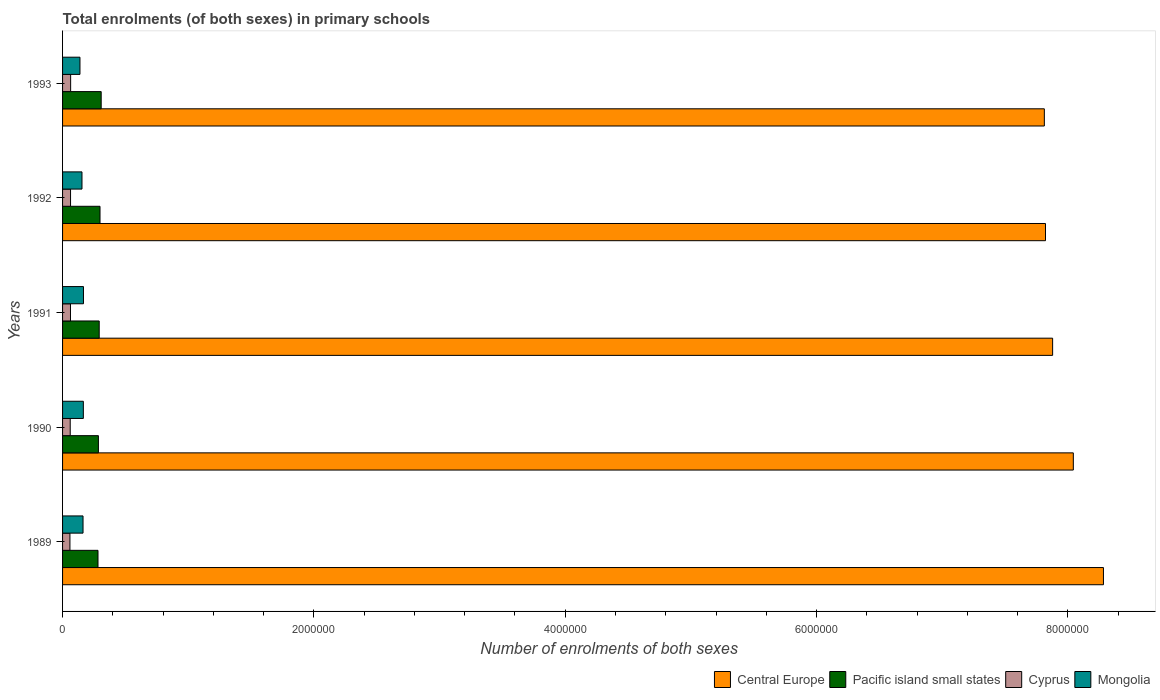Are the number of bars on each tick of the Y-axis equal?
Provide a succinct answer. Yes. What is the label of the 3rd group of bars from the top?
Offer a terse response. 1991. In how many cases, is the number of bars for a given year not equal to the number of legend labels?
Keep it short and to the point. 0. What is the number of enrolments in primary schools in Mongolia in 1993?
Your answer should be very brief. 1.38e+05. Across all years, what is the maximum number of enrolments in primary schools in Central Europe?
Keep it short and to the point. 8.28e+06. Across all years, what is the minimum number of enrolments in primary schools in Central Europe?
Offer a very short reply. 7.81e+06. What is the total number of enrolments in primary schools in Cyprus in the graph?
Your answer should be very brief. 3.10e+05. What is the difference between the number of enrolments in primary schools in Cyprus in 1989 and that in 1990?
Offer a very short reply. -2121. What is the difference between the number of enrolments in primary schools in Pacific island small states in 1991 and the number of enrolments in primary schools in Mongolia in 1989?
Keep it short and to the point. 1.29e+05. What is the average number of enrolments in primary schools in Central Europe per year?
Provide a short and direct response. 7.97e+06. In the year 1992, what is the difference between the number of enrolments in primary schools in Central Europe and number of enrolments in primary schools in Pacific island small states?
Make the answer very short. 7.52e+06. What is the ratio of the number of enrolments in primary schools in Pacific island small states in 1990 to that in 1991?
Provide a succinct answer. 0.98. Is the difference between the number of enrolments in primary schools in Central Europe in 1991 and 1992 greater than the difference between the number of enrolments in primary schools in Pacific island small states in 1991 and 1992?
Your response must be concise. Yes. What is the difference between the highest and the second highest number of enrolments in primary schools in Pacific island small states?
Offer a very short reply. 9341.28. What is the difference between the highest and the lowest number of enrolments in primary schools in Mongolia?
Offer a very short reply. 2.79e+04. In how many years, is the number of enrolments in primary schools in Central Europe greater than the average number of enrolments in primary schools in Central Europe taken over all years?
Your response must be concise. 2. Is the sum of the number of enrolments in primary schools in Central Europe in 1989 and 1990 greater than the maximum number of enrolments in primary schools in Mongolia across all years?
Give a very brief answer. Yes. Is it the case that in every year, the sum of the number of enrolments in primary schools in Mongolia and number of enrolments in primary schools in Cyprus is greater than the sum of number of enrolments in primary schools in Central Europe and number of enrolments in primary schools in Pacific island small states?
Keep it short and to the point. No. What does the 2nd bar from the top in 1991 represents?
Your response must be concise. Cyprus. What does the 1st bar from the bottom in 1989 represents?
Your answer should be very brief. Central Europe. Does the graph contain any zero values?
Offer a very short reply. No. Does the graph contain grids?
Offer a very short reply. No. Where does the legend appear in the graph?
Provide a short and direct response. Bottom right. How many legend labels are there?
Your response must be concise. 4. What is the title of the graph?
Give a very brief answer. Total enrolments (of both sexes) in primary schools. Does "Oman" appear as one of the legend labels in the graph?
Offer a terse response. No. What is the label or title of the X-axis?
Provide a short and direct response. Number of enrolments of both sexes. What is the label or title of the Y-axis?
Provide a short and direct response. Years. What is the Number of enrolments of both sexes in Central Europe in 1989?
Keep it short and to the point. 8.28e+06. What is the Number of enrolments of both sexes in Pacific island small states in 1989?
Provide a succinct answer. 2.82e+05. What is the Number of enrolments of both sexes of Cyprus in 1989?
Give a very brief answer. 5.87e+04. What is the Number of enrolments of both sexes in Mongolia in 1989?
Keep it short and to the point. 1.63e+05. What is the Number of enrolments of both sexes in Central Europe in 1990?
Provide a short and direct response. 8.04e+06. What is the Number of enrolments of both sexes of Pacific island small states in 1990?
Offer a very short reply. 2.85e+05. What is the Number of enrolments of both sexes in Cyprus in 1990?
Make the answer very short. 6.08e+04. What is the Number of enrolments of both sexes in Mongolia in 1990?
Make the answer very short. 1.65e+05. What is the Number of enrolments of both sexes in Central Europe in 1991?
Provide a succinct answer. 7.88e+06. What is the Number of enrolments of both sexes of Pacific island small states in 1991?
Offer a terse response. 2.92e+05. What is the Number of enrolments of both sexes in Cyprus in 1991?
Provide a succinct answer. 6.30e+04. What is the Number of enrolments of both sexes of Mongolia in 1991?
Offer a terse response. 1.66e+05. What is the Number of enrolments of both sexes in Central Europe in 1992?
Provide a short and direct response. 7.82e+06. What is the Number of enrolments of both sexes of Pacific island small states in 1992?
Provide a succinct answer. 2.98e+05. What is the Number of enrolments of both sexes of Cyprus in 1992?
Provide a short and direct response. 6.35e+04. What is the Number of enrolments of both sexes in Mongolia in 1992?
Keep it short and to the point. 1.55e+05. What is the Number of enrolments of both sexes of Central Europe in 1993?
Your response must be concise. 7.81e+06. What is the Number of enrolments of both sexes in Pacific island small states in 1993?
Your response must be concise. 3.07e+05. What is the Number of enrolments of both sexes in Cyprus in 1993?
Offer a terse response. 6.43e+04. What is the Number of enrolments of both sexes of Mongolia in 1993?
Offer a very short reply. 1.38e+05. Across all years, what is the maximum Number of enrolments of both sexes of Central Europe?
Keep it short and to the point. 8.28e+06. Across all years, what is the maximum Number of enrolments of both sexes in Pacific island small states?
Your answer should be compact. 3.07e+05. Across all years, what is the maximum Number of enrolments of both sexes in Cyprus?
Make the answer very short. 6.43e+04. Across all years, what is the maximum Number of enrolments of both sexes in Mongolia?
Ensure brevity in your answer.  1.66e+05. Across all years, what is the minimum Number of enrolments of both sexes of Central Europe?
Keep it short and to the point. 7.81e+06. Across all years, what is the minimum Number of enrolments of both sexes in Pacific island small states?
Offer a terse response. 2.82e+05. Across all years, what is the minimum Number of enrolments of both sexes in Cyprus?
Provide a short and direct response. 5.87e+04. Across all years, what is the minimum Number of enrolments of both sexes in Mongolia?
Your answer should be very brief. 1.38e+05. What is the total Number of enrolments of both sexes in Central Europe in the graph?
Offer a very short reply. 3.98e+07. What is the total Number of enrolments of both sexes in Pacific island small states in the graph?
Provide a succinct answer. 1.46e+06. What is the total Number of enrolments of both sexes in Cyprus in the graph?
Provide a short and direct response. 3.10e+05. What is the total Number of enrolments of both sexes of Mongolia in the graph?
Make the answer very short. 7.88e+05. What is the difference between the Number of enrolments of both sexes of Central Europe in 1989 and that in 1990?
Offer a very short reply. 2.40e+05. What is the difference between the Number of enrolments of both sexes of Pacific island small states in 1989 and that in 1990?
Offer a terse response. -3343.72. What is the difference between the Number of enrolments of both sexes of Cyprus in 1989 and that in 1990?
Your answer should be very brief. -2121. What is the difference between the Number of enrolments of both sexes of Mongolia in 1989 and that in 1990?
Ensure brevity in your answer.  -2500. What is the difference between the Number of enrolments of both sexes of Central Europe in 1989 and that in 1991?
Your answer should be compact. 4.04e+05. What is the difference between the Number of enrolments of both sexes of Pacific island small states in 1989 and that in 1991?
Offer a very short reply. -9645.75. What is the difference between the Number of enrolments of both sexes in Cyprus in 1989 and that in 1991?
Offer a very short reply. -4242. What is the difference between the Number of enrolments of both sexes of Mongolia in 1989 and that in 1991?
Your response must be concise. -3449. What is the difference between the Number of enrolments of both sexes of Central Europe in 1989 and that in 1992?
Keep it short and to the point. 4.61e+05. What is the difference between the Number of enrolments of both sexes in Pacific island small states in 1989 and that in 1992?
Offer a very short reply. -1.61e+04. What is the difference between the Number of enrolments of both sexes of Cyprus in 1989 and that in 1992?
Give a very brief answer. -4734. What is the difference between the Number of enrolments of both sexes of Mongolia in 1989 and that in 1992?
Provide a short and direct response. 8312. What is the difference between the Number of enrolments of both sexes in Central Europe in 1989 and that in 1993?
Offer a very short reply. 4.70e+05. What is the difference between the Number of enrolments of both sexes of Pacific island small states in 1989 and that in 1993?
Your answer should be very brief. -2.54e+04. What is the difference between the Number of enrolments of both sexes in Cyprus in 1989 and that in 1993?
Your response must be concise. -5593. What is the difference between the Number of enrolments of both sexes of Mongolia in 1989 and that in 1993?
Offer a terse response. 2.45e+04. What is the difference between the Number of enrolments of both sexes of Central Europe in 1990 and that in 1991?
Offer a very short reply. 1.65e+05. What is the difference between the Number of enrolments of both sexes of Pacific island small states in 1990 and that in 1991?
Provide a short and direct response. -6302.03. What is the difference between the Number of enrolments of both sexes in Cyprus in 1990 and that in 1991?
Provide a short and direct response. -2121. What is the difference between the Number of enrolments of both sexes of Mongolia in 1990 and that in 1991?
Offer a very short reply. -949. What is the difference between the Number of enrolments of both sexes of Central Europe in 1990 and that in 1992?
Keep it short and to the point. 2.22e+05. What is the difference between the Number of enrolments of both sexes in Pacific island small states in 1990 and that in 1992?
Offer a terse response. -1.27e+04. What is the difference between the Number of enrolments of both sexes of Cyprus in 1990 and that in 1992?
Provide a short and direct response. -2613. What is the difference between the Number of enrolments of both sexes of Mongolia in 1990 and that in 1992?
Your answer should be very brief. 1.08e+04. What is the difference between the Number of enrolments of both sexes of Central Europe in 1990 and that in 1993?
Provide a succinct answer. 2.31e+05. What is the difference between the Number of enrolments of both sexes of Pacific island small states in 1990 and that in 1993?
Your answer should be compact. -2.21e+04. What is the difference between the Number of enrolments of both sexes in Cyprus in 1990 and that in 1993?
Give a very brief answer. -3472. What is the difference between the Number of enrolments of both sexes of Mongolia in 1990 and that in 1993?
Make the answer very short. 2.70e+04. What is the difference between the Number of enrolments of both sexes of Central Europe in 1991 and that in 1992?
Offer a terse response. 5.67e+04. What is the difference between the Number of enrolments of both sexes in Pacific island small states in 1991 and that in 1992?
Make the answer very short. -6427.69. What is the difference between the Number of enrolments of both sexes of Cyprus in 1991 and that in 1992?
Offer a very short reply. -492. What is the difference between the Number of enrolments of both sexes in Mongolia in 1991 and that in 1992?
Provide a succinct answer. 1.18e+04. What is the difference between the Number of enrolments of both sexes in Central Europe in 1991 and that in 1993?
Your answer should be very brief. 6.59e+04. What is the difference between the Number of enrolments of both sexes in Pacific island small states in 1991 and that in 1993?
Offer a very short reply. -1.58e+04. What is the difference between the Number of enrolments of both sexes in Cyprus in 1991 and that in 1993?
Make the answer very short. -1351. What is the difference between the Number of enrolments of both sexes in Mongolia in 1991 and that in 1993?
Make the answer very short. 2.79e+04. What is the difference between the Number of enrolments of both sexes of Central Europe in 1992 and that in 1993?
Your response must be concise. 9198. What is the difference between the Number of enrolments of both sexes in Pacific island small states in 1992 and that in 1993?
Your answer should be compact. -9341.28. What is the difference between the Number of enrolments of both sexes of Cyprus in 1992 and that in 1993?
Keep it short and to the point. -859. What is the difference between the Number of enrolments of both sexes of Mongolia in 1992 and that in 1993?
Keep it short and to the point. 1.62e+04. What is the difference between the Number of enrolments of both sexes of Central Europe in 1989 and the Number of enrolments of both sexes of Pacific island small states in 1990?
Give a very brief answer. 8.00e+06. What is the difference between the Number of enrolments of both sexes in Central Europe in 1989 and the Number of enrolments of both sexes in Cyprus in 1990?
Keep it short and to the point. 8.22e+06. What is the difference between the Number of enrolments of both sexes of Central Europe in 1989 and the Number of enrolments of both sexes of Mongolia in 1990?
Provide a succinct answer. 8.12e+06. What is the difference between the Number of enrolments of both sexes of Pacific island small states in 1989 and the Number of enrolments of both sexes of Cyprus in 1990?
Your answer should be compact. 2.21e+05. What is the difference between the Number of enrolments of both sexes of Pacific island small states in 1989 and the Number of enrolments of both sexes of Mongolia in 1990?
Provide a short and direct response. 1.17e+05. What is the difference between the Number of enrolments of both sexes in Cyprus in 1989 and the Number of enrolments of both sexes in Mongolia in 1990?
Ensure brevity in your answer.  -1.07e+05. What is the difference between the Number of enrolments of both sexes of Central Europe in 1989 and the Number of enrolments of both sexes of Pacific island small states in 1991?
Provide a succinct answer. 7.99e+06. What is the difference between the Number of enrolments of both sexes in Central Europe in 1989 and the Number of enrolments of both sexes in Cyprus in 1991?
Provide a short and direct response. 8.22e+06. What is the difference between the Number of enrolments of both sexes in Central Europe in 1989 and the Number of enrolments of both sexes in Mongolia in 1991?
Offer a terse response. 8.12e+06. What is the difference between the Number of enrolments of both sexes of Pacific island small states in 1989 and the Number of enrolments of both sexes of Cyprus in 1991?
Your answer should be compact. 2.19e+05. What is the difference between the Number of enrolments of both sexes of Pacific island small states in 1989 and the Number of enrolments of both sexes of Mongolia in 1991?
Give a very brief answer. 1.16e+05. What is the difference between the Number of enrolments of both sexes in Cyprus in 1989 and the Number of enrolments of both sexes in Mongolia in 1991?
Give a very brief answer. -1.08e+05. What is the difference between the Number of enrolments of both sexes of Central Europe in 1989 and the Number of enrolments of both sexes of Pacific island small states in 1992?
Your response must be concise. 7.99e+06. What is the difference between the Number of enrolments of both sexes of Central Europe in 1989 and the Number of enrolments of both sexes of Cyprus in 1992?
Offer a terse response. 8.22e+06. What is the difference between the Number of enrolments of both sexes in Central Europe in 1989 and the Number of enrolments of both sexes in Mongolia in 1992?
Your answer should be very brief. 8.13e+06. What is the difference between the Number of enrolments of both sexes in Pacific island small states in 1989 and the Number of enrolments of both sexes in Cyprus in 1992?
Offer a terse response. 2.18e+05. What is the difference between the Number of enrolments of both sexes of Pacific island small states in 1989 and the Number of enrolments of both sexes of Mongolia in 1992?
Your response must be concise. 1.27e+05. What is the difference between the Number of enrolments of both sexes of Cyprus in 1989 and the Number of enrolments of both sexes of Mongolia in 1992?
Keep it short and to the point. -9.59e+04. What is the difference between the Number of enrolments of both sexes in Central Europe in 1989 and the Number of enrolments of both sexes in Pacific island small states in 1993?
Provide a succinct answer. 7.98e+06. What is the difference between the Number of enrolments of both sexes of Central Europe in 1989 and the Number of enrolments of both sexes of Cyprus in 1993?
Ensure brevity in your answer.  8.22e+06. What is the difference between the Number of enrolments of both sexes of Central Europe in 1989 and the Number of enrolments of both sexes of Mongolia in 1993?
Provide a succinct answer. 8.14e+06. What is the difference between the Number of enrolments of both sexes in Pacific island small states in 1989 and the Number of enrolments of both sexes in Cyprus in 1993?
Keep it short and to the point. 2.18e+05. What is the difference between the Number of enrolments of both sexes of Pacific island small states in 1989 and the Number of enrolments of both sexes of Mongolia in 1993?
Make the answer very short. 1.43e+05. What is the difference between the Number of enrolments of both sexes of Cyprus in 1989 and the Number of enrolments of both sexes of Mongolia in 1993?
Provide a short and direct response. -7.97e+04. What is the difference between the Number of enrolments of both sexes of Central Europe in 1990 and the Number of enrolments of both sexes of Pacific island small states in 1991?
Provide a succinct answer. 7.75e+06. What is the difference between the Number of enrolments of both sexes of Central Europe in 1990 and the Number of enrolments of both sexes of Cyprus in 1991?
Your answer should be very brief. 7.98e+06. What is the difference between the Number of enrolments of both sexes of Central Europe in 1990 and the Number of enrolments of both sexes of Mongolia in 1991?
Your answer should be compact. 7.88e+06. What is the difference between the Number of enrolments of both sexes of Pacific island small states in 1990 and the Number of enrolments of both sexes of Cyprus in 1991?
Offer a terse response. 2.22e+05. What is the difference between the Number of enrolments of both sexes of Pacific island small states in 1990 and the Number of enrolments of both sexes of Mongolia in 1991?
Offer a very short reply. 1.19e+05. What is the difference between the Number of enrolments of both sexes of Cyprus in 1990 and the Number of enrolments of both sexes of Mongolia in 1991?
Offer a very short reply. -1.06e+05. What is the difference between the Number of enrolments of both sexes in Central Europe in 1990 and the Number of enrolments of both sexes in Pacific island small states in 1992?
Keep it short and to the point. 7.75e+06. What is the difference between the Number of enrolments of both sexes of Central Europe in 1990 and the Number of enrolments of both sexes of Cyprus in 1992?
Offer a terse response. 7.98e+06. What is the difference between the Number of enrolments of both sexes of Central Europe in 1990 and the Number of enrolments of both sexes of Mongolia in 1992?
Offer a very short reply. 7.89e+06. What is the difference between the Number of enrolments of both sexes of Pacific island small states in 1990 and the Number of enrolments of both sexes of Cyprus in 1992?
Your answer should be compact. 2.22e+05. What is the difference between the Number of enrolments of both sexes of Pacific island small states in 1990 and the Number of enrolments of both sexes of Mongolia in 1992?
Make the answer very short. 1.31e+05. What is the difference between the Number of enrolments of both sexes in Cyprus in 1990 and the Number of enrolments of both sexes in Mongolia in 1992?
Offer a very short reply. -9.37e+04. What is the difference between the Number of enrolments of both sexes in Central Europe in 1990 and the Number of enrolments of both sexes in Pacific island small states in 1993?
Keep it short and to the point. 7.74e+06. What is the difference between the Number of enrolments of both sexes in Central Europe in 1990 and the Number of enrolments of both sexes in Cyprus in 1993?
Offer a terse response. 7.98e+06. What is the difference between the Number of enrolments of both sexes in Central Europe in 1990 and the Number of enrolments of both sexes in Mongolia in 1993?
Make the answer very short. 7.90e+06. What is the difference between the Number of enrolments of both sexes in Pacific island small states in 1990 and the Number of enrolments of both sexes in Cyprus in 1993?
Provide a succinct answer. 2.21e+05. What is the difference between the Number of enrolments of both sexes of Pacific island small states in 1990 and the Number of enrolments of both sexes of Mongolia in 1993?
Your answer should be very brief. 1.47e+05. What is the difference between the Number of enrolments of both sexes in Cyprus in 1990 and the Number of enrolments of both sexes in Mongolia in 1993?
Ensure brevity in your answer.  -7.76e+04. What is the difference between the Number of enrolments of both sexes in Central Europe in 1991 and the Number of enrolments of both sexes in Pacific island small states in 1992?
Your response must be concise. 7.58e+06. What is the difference between the Number of enrolments of both sexes of Central Europe in 1991 and the Number of enrolments of both sexes of Cyprus in 1992?
Provide a succinct answer. 7.82e+06. What is the difference between the Number of enrolments of both sexes in Central Europe in 1991 and the Number of enrolments of both sexes in Mongolia in 1992?
Your answer should be very brief. 7.72e+06. What is the difference between the Number of enrolments of both sexes of Pacific island small states in 1991 and the Number of enrolments of both sexes of Cyprus in 1992?
Provide a succinct answer. 2.28e+05. What is the difference between the Number of enrolments of both sexes of Pacific island small states in 1991 and the Number of enrolments of both sexes of Mongolia in 1992?
Offer a very short reply. 1.37e+05. What is the difference between the Number of enrolments of both sexes in Cyprus in 1991 and the Number of enrolments of both sexes in Mongolia in 1992?
Provide a short and direct response. -9.16e+04. What is the difference between the Number of enrolments of both sexes of Central Europe in 1991 and the Number of enrolments of both sexes of Pacific island small states in 1993?
Keep it short and to the point. 7.57e+06. What is the difference between the Number of enrolments of both sexes of Central Europe in 1991 and the Number of enrolments of both sexes of Cyprus in 1993?
Ensure brevity in your answer.  7.81e+06. What is the difference between the Number of enrolments of both sexes of Central Europe in 1991 and the Number of enrolments of both sexes of Mongolia in 1993?
Your answer should be very brief. 7.74e+06. What is the difference between the Number of enrolments of both sexes in Pacific island small states in 1991 and the Number of enrolments of both sexes in Cyprus in 1993?
Offer a very short reply. 2.27e+05. What is the difference between the Number of enrolments of both sexes in Pacific island small states in 1991 and the Number of enrolments of both sexes in Mongolia in 1993?
Keep it short and to the point. 1.53e+05. What is the difference between the Number of enrolments of both sexes of Cyprus in 1991 and the Number of enrolments of both sexes of Mongolia in 1993?
Provide a succinct answer. -7.55e+04. What is the difference between the Number of enrolments of both sexes of Central Europe in 1992 and the Number of enrolments of both sexes of Pacific island small states in 1993?
Your answer should be very brief. 7.51e+06. What is the difference between the Number of enrolments of both sexes of Central Europe in 1992 and the Number of enrolments of both sexes of Cyprus in 1993?
Provide a succinct answer. 7.76e+06. What is the difference between the Number of enrolments of both sexes in Central Europe in 1992 and the Number of enrolments of both sexes in Mongolia in 1993?
Ensure brevity in your answer.  7.68e+06. What is the difference between the Number of enrolments of both sexes in Pacific island small states in 1992 and the Number of enrolments of both sexes in Cyprus in 1993?
Ensure brevity in your answer.  2.34e+05. What is the difference between the Number of enrolments of both sexes of Pacific island small states in 1992 and the Number of enrolments of both sexes of Mongolia in 1993?
Provide a succinct answer. 1.60e+05. What is the difference between the Number of enrolments of both sexes in Cyprus in 1992 and the Number of enrolments of both sexes in Mongolia in 1993?
Provide a short and direct response. -7.50e+04. What is the average Number of enrolments of both sexes in Central Europe per year?
Offer a very short reply. 7.97e+06. What is the average Number of enrolments of both sexes in Pacific island small states per year?
Your response must be concise. 2.93e+05. What is the average Number of enrolments of both sexes in Cyprus per year?
Your answer should be very brief. 6.21e+04. What is the average Number of enrolments of both sexes of Mongolia per year?
Provide a succinct answer. 1.58e+05. In the year 1989, what is the difference between the Number of enrolments of both sexes in Central Europe and Number of enrolments of both sexes in Pacific island small states?
Your response must be concise. 8.00e+06. In the year 1989, what is the difference between the Number of enrolments of both sexes in Central Europe and Number of enrolments of both sexes in Cyprus?
Give a very brief answer. 8.22e+06. In the year 1989, what is the difference between the Number of enrolments of both sexes in Central Europe and Number of enrolments of both sexes in Mongolia?
Keep it short and to the point. 8.12e+06. In the year 1989, what is the difference between the Number of enrolments of both sexes of Pacific island small states and Number of enrolments of both sexes of Cyprus?
Your answer should be very brief. 2.23e+05. In the year 1989, what is the difference between the Number of enrolments of both sexes in Pacific island small states and Number of enrolments of both sexes in Mongolia?
Offer a very short reply. 1.19e+05. In the year 1989, what is the difference between the Number of enrolments of both sexes of Cyprus and Number of enrolments of both sexes of Mongolia?
Ensure brevity in your answer.  -1.04e+05. In the year 1990, what is the difference between the Number of enrolments of both sexes of Central Europe and Number of enrolments of both sexes of Pacific island small states?
Make the answer very short. 7.76e+06. In the year 1990, what is the difference between the Number of enrolments of both sexes in Central Europe and Number of enrolments of both sexes in Cyprus?
Your answer should be compact. 7.98e+06. In the year 1990, what is the difference between the Number of enrolments of both sexes of Central Europe and Number of enrolments of both sexes of Mongolia?
Ensure brevity in your answer.  7.88e+06. In the year 1990, what is the difference between the Number of enrolments of both sexes in Pacific island small states and Number of enrolments of both sexes in Cyprus?
Keep it short and to the point. 2.24e+05. In the year 1990, what is the difference between the Number of enrolments of both sexes in Pacific island small states and Number of enrolments of both sexes in Mongolia?
Provide a succinct answer. 1.20e+05. In the year 1990, what is the difference between the Number of enrolments of both sexes in Cyprus and Number of enrolments of both sexes in Mongolia?
Make the answer very short. -1.05e+05. In the year 1991, what is the difference between the Number of enrolments of both sexes in Central Europe and Number of enrolments of both sexes in Pacific island small states?
Offer a very short reply. 7.59e+06. In the year 1991, what is the difference between the Number of enrolments of both sexes in Central Europe and Number of enrolments of both sexes in Cyprus?
Offer a terse response. 7.82e+06. In the year 1991, what is the difference between the Number of enrolments of both sexes in Central Europe and Number of enrolments of both sexes in Mongolia?
Provide a short and direct response. 7.71e+06. In the year 1991, what is the difference between the Number of enrolments of both sexes in Pacific island small states and Number of enrolments of both sexes in Cyprus?
Ensure brevity in your answer.  2.29e+05. In the year 1991, what is the difference between the Number of enrolments of both sexes of Pacific island small states and Number of enrolments of both sexes of Mongolia?
Provide a succinct answer. 1.25e+05. In the year 1991, what is the difference between the Number of enrolments of both sexes of Cyprus and Number of enrolments of both sexes of Mongolia?
Your answer should be very brief. -1.03e+05. In the year 1992, what is the difference between the Number of enrolments of both sexes of Central Europe and Number of enrolments of both sexes of Pacific island small states?
Your answer should be very brief. 7.52e+06. In the year 1992, what is the difference between the Number of enrolments of both sexes in Central Europe and Number of enrolments of both sexes in Cyprus?
Provide a short and direct response. 7.76e+06. In the year 1992, what is the difference between the Number of enrolments of both sexes of Central Europe and Number of enrolments of both sexes of Mongolia?
Provide a succinct answer. 7.67e+06. In the year 1992, what is the difference between the Number of enrolments of both sexes in Pacific island small states and Number of enrolments of both sexes in Cyprus?
Provide a succinct answer. 2.35e+05. In the year 1992, what is the difference between the Number of enrolments of both sexes in Pacific island small states and Number of enrolments of both sexes in Mongolia?
Provide a short and direct response. 1.43e+05. In the year 1992, what is the difference between the Number of enrolments of both sexes in Cyprus and Number of enrolments of both sexes in Mongolia?
Ensure brevity in your answer.  -9.11e+04. In the year 1993, what is the difference between the Number of enrolments of both sexes of Central Europe and Number of enrolments of both sexes of Pacific island small states?
Provide a succinct answer. 7.51e+06. In the year 1993, what is the difference between the Number of enrolments of both sexes of Central Europe and Number of enrolments of both sexes of Cyprus?
Your answer should be compact. 7.75e+06. In the year 1993, what is the difference between the Number of enrolments of both sexes of Central Europe and Number of enrolments of both sexes of Mongolia?
Give a very brief answer. 7.67e+06. In the year 1993, what is the difference between the Number of enrolments of both sexes of Pacific island small states and Number of enrolments of both sexes of Cyprus?
Your answer should be compact. 2.43e+05. In the year 1993, what is the difference between the Number of enrolments of both sexes of Pacific island small states and Number of enrolments of both sexes of Mongolia?
Make the answer very short. 1.69e+05. In the year 1993, what is the difference between the Number of enrolments of both sexes of Cyprus and Number of enrolments of both sexes of Mongolia?
Offer a very short reply. -7.41e+04. What is the ratio of the Number of enrolments of both sexes of Central Europe in 1989 to that in 1990?
Provide a succinct answer. 1.03. What is the ratio of the Number of enrolments of both sexes in Pacific island small states in 1989 to that in 1990?
Provide a short and direct response. 0.99. What is the ratio of the Number of enrolments of both sexes in Cyprus in 1989 to that in 1990?
Your answer should be compact. 0.97. What is the ratio of the Number of enrolments of both sexes in Mongolia in 1989 to that in 1990?
Your answer should be very brief. 0.98. What is the ratio of the Number of enrolments of both sexes in Central Europe in 1989 to that in 1991?
Your answer should be very brief. 1.05. What is the ratio of the Number of enrolments of both sexes in Pacific island small states in 1989 to that in 1991?
Ensure brevity in your answer.  0.97. What is the ratio of the Number of enrolments of both sexes in Cyprus in 1989 to that in 1991?
Ensure brevity in your answer.  0.93. What is the ratio of the Number of enrolments of both sexes of Mongolia in 1989 to that in 1991?
Offer a very short reply. 0.98. What is the ratio of the Number of enrolments of both sexes of Central Europe in 1989 to that in 1992?
Your answer should be compact. 1.06. What is the ratio of the Number of enrolments of both sexes in Pacific island small states in 1989 to that in 1992?
Keep it short and to the point. 0.95. What is the ratio of the Number of enrolments of both sexes in Cyprus in 1989 to that in 1992?
Provide a short and direct response. 0.93. What is the ratio of the Number of enrolments of both sexes of Mongolia in 1989 to that in 1992?
Offer a terse response. 1.05. What is the ratio of the Number of enrolments of both sexes of Central Europe in 1989 to that in 1993?
Offer a very short reply. 1.06. What is the ratio of the Number of enrolments of both sexes in Pacific island small states in 1989 to that in 1993?
Make the answer very short. 0.92. What is the ratio of the Number of enrolments of both sexes in Mongolia in 1989 to that in 1993?
Your answer should be very brief. 1.18. What is the ratio of the Number of enrolments of both sexes in Central Europe in 1990 to that in 1991?
Your response must be concise. 1.02. What is the ratio of the Number of enrolments of both sexes in Pacific island small states in 1990 to that in 1991?
Provide a short and direct response. 0.98. What is the ratio of the Number of enrolments of both sexes in Cyprus in 1990 to that in 1991?
Your answer should be very brief. 0.97. What is the ratio of the Number of enrolments of both sexes of Central Europe in 1990 to that in 1992?
Offer a terse response. 1.03. What is the ratio of the Number of enrolments of both sexes of Pacific island small states in 1990 to that in 1992?
Provide a succinct answer. 0.96. What is the ratio of the Number of enrolments of both sexes of Cyprus in 1990 to that in 1992?
Ensure brevity in your answer.  0.96. What is the ratio of the Number of enrolments of both sexes in Mongolia in 1990 to that in 1992?
Keep it short and to the point. 1.07. What is the ratio of the Number of enrolments of both sexes of Central Europe in 1990 to that in 1993?
Give a very brief answer. 1.03. What is the ratio of the Number of enrolments of both sexes in Pacific island small states in 1990 to that in 1993?
Give a very brief answer. 0.93. What is the ratio of the Number of enrolments of both sexes of Cyprus in 1990 to that in 1993?
Offer a terse response. 0.95. What is the ratio of the Number of enrolments of both sexes of Mongolia in 1990 to that in 1993?
Offer a very short reply. 1.19. What is the ratio of the Number of enrolments of both sexes in Central Europe in 1991 to that in 1992?
Offer a very short reply. 1.01. What is the ratio of the Number of enrolments of both sexes of Pacific island small states in 1991 to that in 1992?
Give a very brief answer. 0.98. What is the ratio of the Number of enrolments of both sexes in Mongolia in 1991 to that in 1992?
Your response must be concise. 1.08. What is the ratio of the Number of enrolments of both sexes in Central Europe in 1991 to that in 1993?
Make the answer very short. 1.01. What is the ratio of the Number of enrolments of both sexes of Pacific island small states in 1991 to that in 1993?
Provide a succinct answer. 0.95. What is the ratio of the Number of enrolments of both sexes of Mongolia in 1991 to that in 1993?
Make the answer very short. 1.2. What is the ratio of the Number of enrolments of both sexes in Pacific island small states in 1992 to that in 1993?
Keep it short and to the point. 0.97. What is the ratio of the Number of enrolments of both sexes of Cyprus in 1992 to that in 1993?
Offer a terse response. 0.99. What is the ratio of the Number of enrolments of both sexes in Mongolia in 1992 to that in 1993?
Your response must be concise. 1.12. What is the difference between the highest and the second highest Number of enrolments of both sexes of Central Europe?
Offer a terse response. 2.40e+05. What is the difference between the highest and the second highest Number of enrolments of both sexes of Pacific island small states?
Provide a succinct answer. 9341.28. What is the difference between the highest and the second highest Number of enrolments of both sexes of Cyprus?
Your answer should be very brief. 859. What is the difference between the highest and the second highest Number of enrolments of both sexes in Mongolia?
Provide a short and direct response. 949. What is the difference between the highest and the lowest Number of enrolments of both sexes in Central Europe?
Provide a succinct answer. 4.70e+05. What is the difference between the highest and the lowest Number of enrolments of both sexes of Pacific island small states?
Provide a short and direct response. 2.54e+04. What is the difference between the highest and the lowest Number of enrolments of both sexes of Cyprus?
Give a very brief answer. 5593. What is the difference between the highest and the lowest Number of enrolments of both sexes of Mongolia?
Offer a terse response. 2.79e+04. 